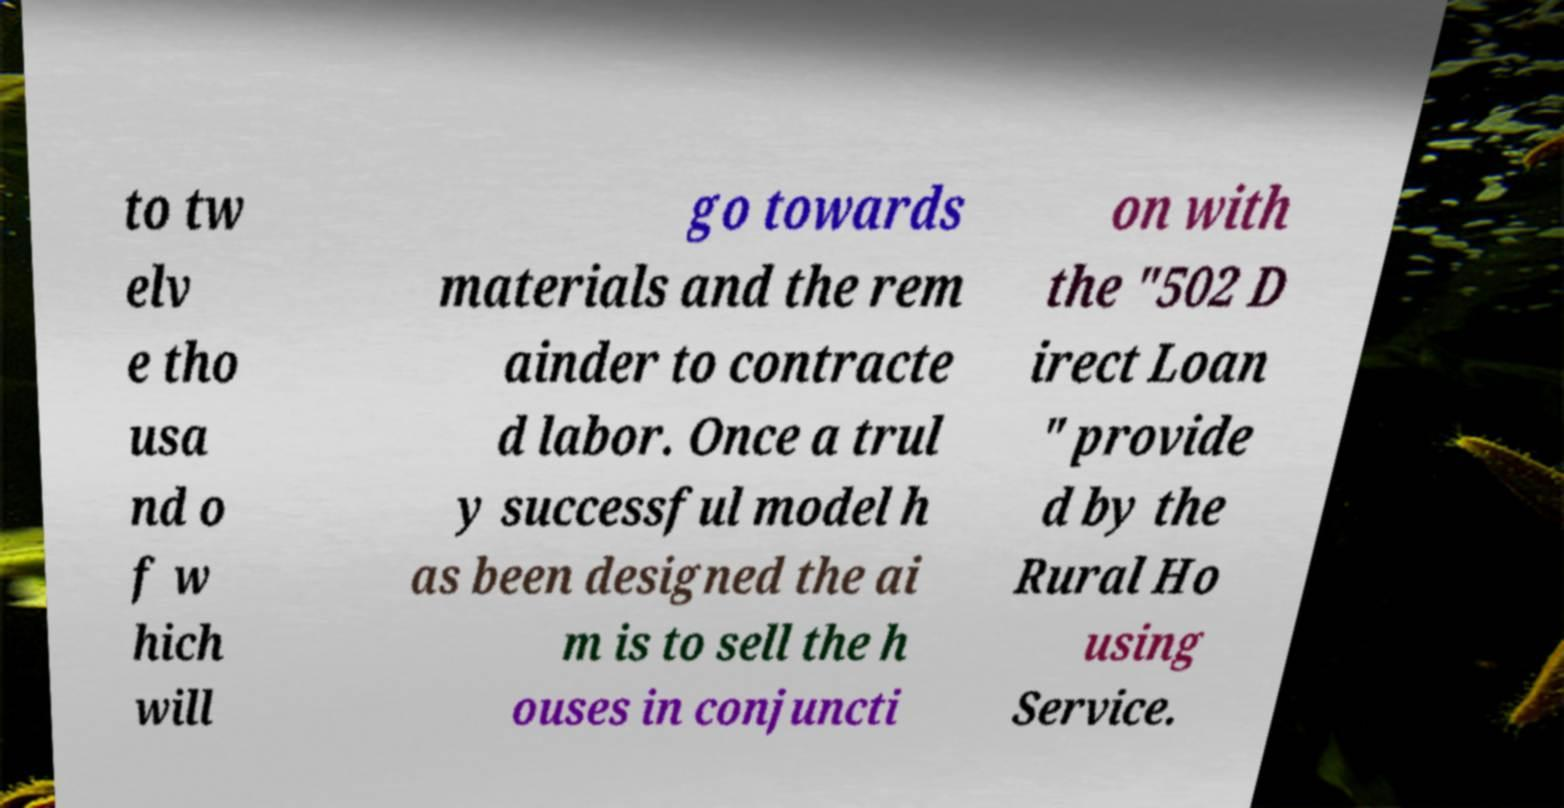I need the written content from this picture converted into text. Can you do that? to tw elv e tho usa nd o f w hich will go towards materials and the rem ainder to contracte d labor. Once a trul y successful model h as been designed the ai m is to sell the h ouses in conjuncti on with the "502 D irect Loan " provide d by the Rural Ho using Service. 